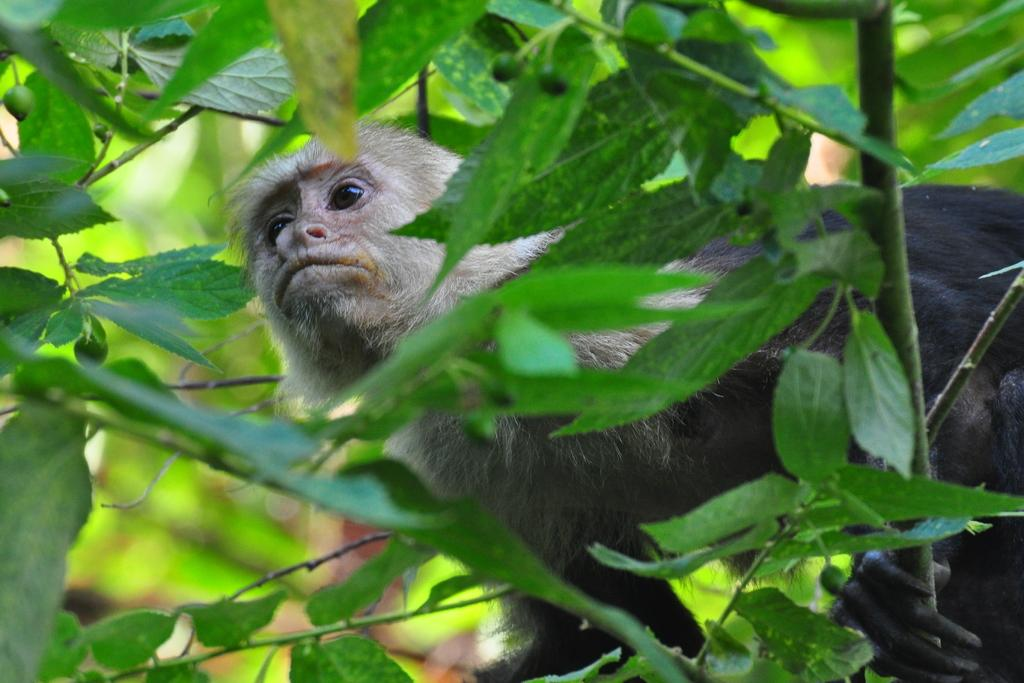What animal is present in the image? There is a monkey in the image. Can you describe the appearance of the monkey? The monkey is brown and white in color. Where is the monkey located in the image? The monkey is on a tree. What is the color of the tree? The tree is green in color. What type of battle is taking place in the image? There is no battle present in the image; it features a monkey on a tree. How many cattle can be seen grazing in the image? There are no cattle present in the image. 